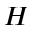Convert formula to latex. <formula><loc_0><loc_0><loc_500><loc_500>H</formula> 